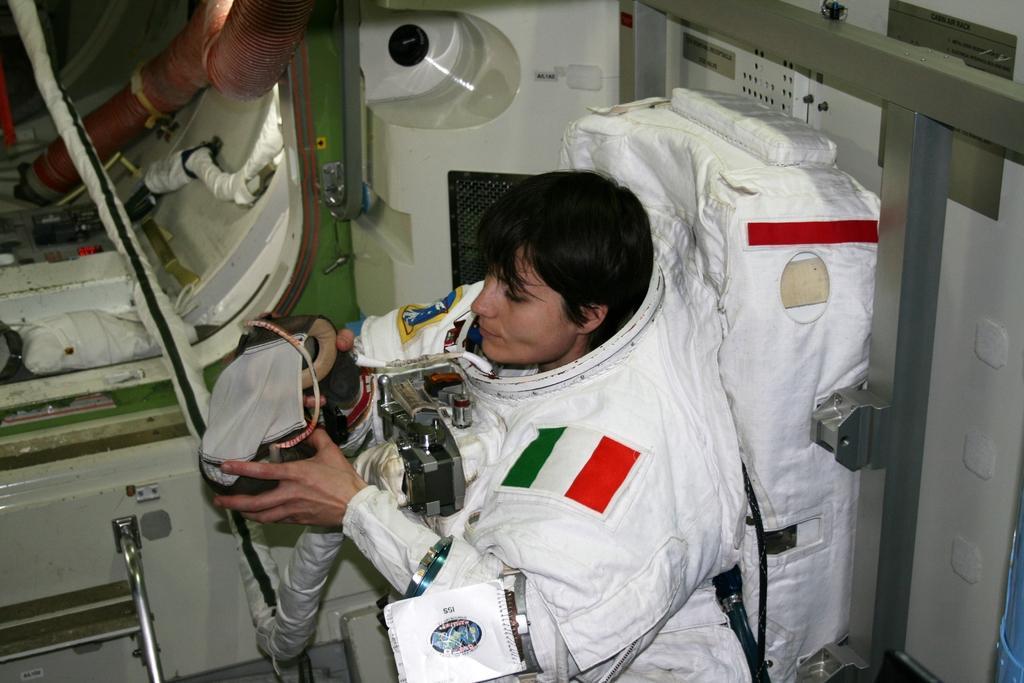Can you describe this image briefly? In the foreground of this picture, there is a woman in space suit and also holding a machine in her hand. In the background, we can see pipes, door of a spaceship. 